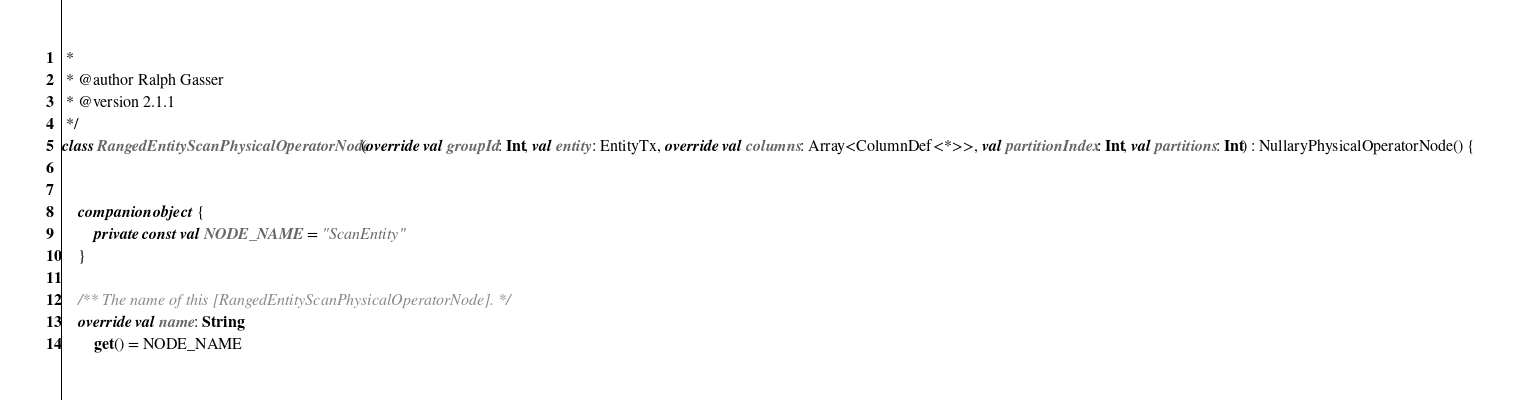<code> <loc_0><loc_0><loc_500><loc_500><_Kotlin_> *
 * @author Ralph Gasser
 * @version 2.1.1
 */
class RangedEntityScanPhysicalOperatorNode(override val groupId: Int, val entity: EntityTx, override val columns: Array<ColumnDef<*>>, val partitionIndex: Int, val partitions: Int) : NullaryPhysicalOperatorNode() {


    companion object {
        private const val NODE_NAME = "ScanEntity"
    }

    /** The name of this [RangedEntityScanPhysicalOperatorNode]. */
    override val name: String
        get() = NODE_NAME

</code> 